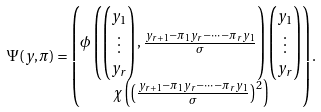<formula> <loc_0><loc_0><loc_500><loc_500>& \Psi ( y , \pi ) = \begin{pmatrix} \phi \left ( \begin{pmatrix} y _ { 1 } \\ \vdots \\ y _ { r } \end{pmatrix} , \frac { y _ { r + 1 } - \pi _ { 1 } y _ { r } - \dots - \pi _ { r } y _ { 1 } } { \sigma } \right ) \begin{pmatrix} y _ { 1 } \\ \vdots \\ y _ { r } \end{pmatrix} \\ \chi \left ( \left ( \frac { y _ { r + 1 } - \pi _ { 1 } y _ { r } - \dots - \pi _ { r } y _ { 1 } } { \sigma } \right ) ^ { 2 } \right ) \end{pmatrix} .</formula> 